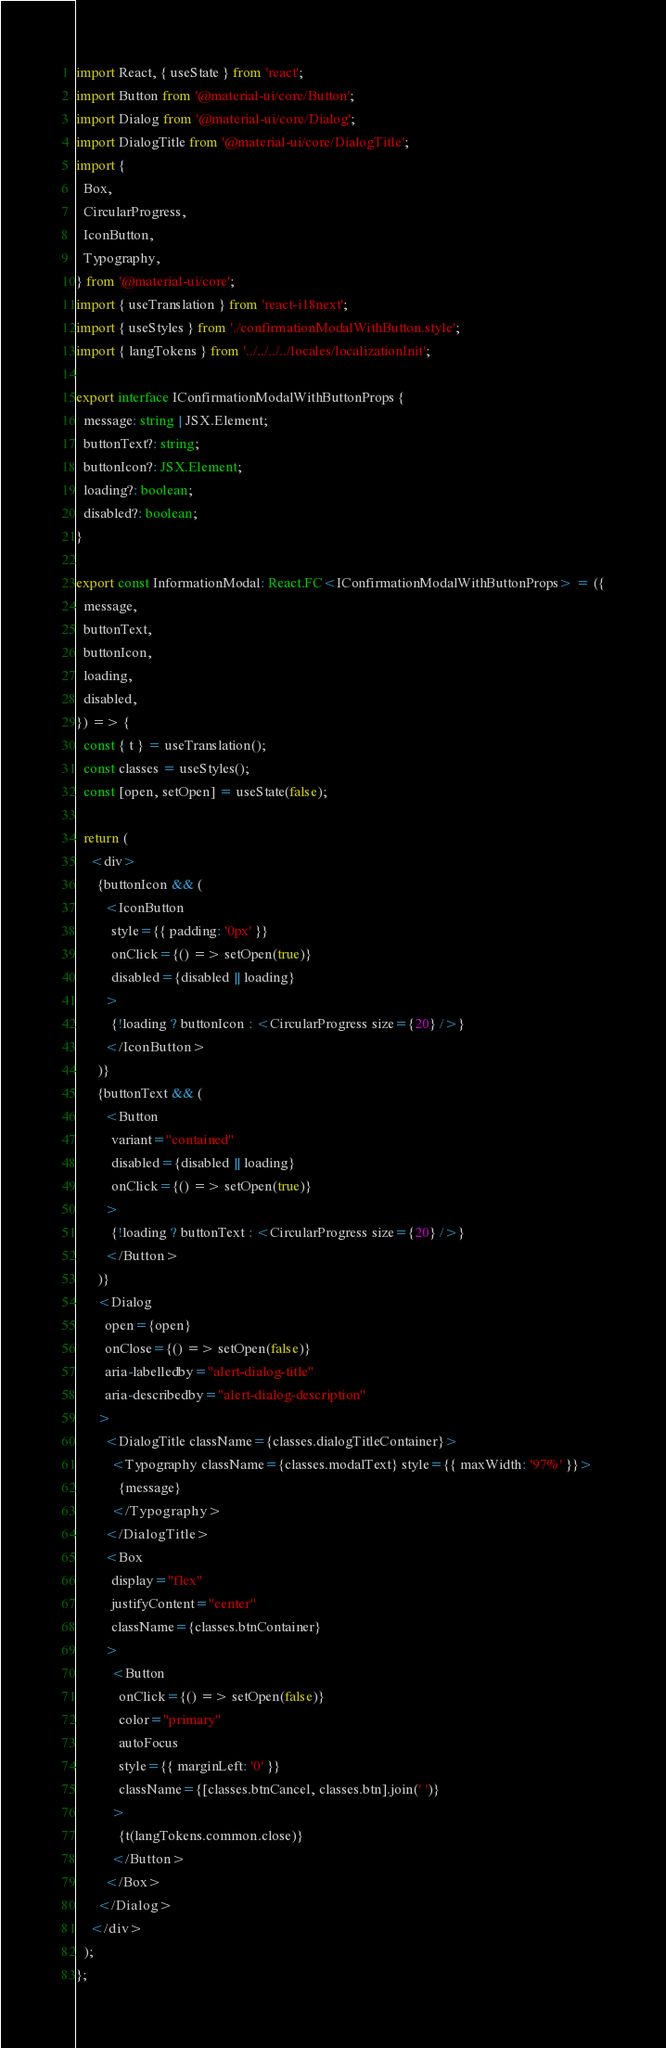<code> <loc_0><loc_0><loc_500><loc_500><_TypeScript_>import React, { useState } from 'react';
import Button from '@material-ui/core/Button';
import Dialog from '@material-ui/core/Dialog';
import DialogTitle from '@material-ui/core/DialogTitle';
import {
  Box,
  CircularProgress,
  IconButton,
  Typography,
} from '@material-ui/core';
import { useTranslation } from 'react-i18next';
import { useStyles } from './confirmationModalWithButton.style';
import { langTokens } from '../../../../locales/localizationInit';

export interface IConfirmationModalWithButtonProps {
  message: string | JSX.Element;
  buttonText?: string;
  buttonIcon?: JSX.Element;
  loading?: boolean;
  disabled?: boolean;
}

export const InformationModal: React.FC<IConfirmationModalWithButtonProps> = ({
  message,
  buttonText,
  buttonIcon,
  loading,
  disabled,
}) => {
  const { t } = useTranslation();
  const classes = useStyles();
  const [open, setOpen] = useState(false);

  return (
    <div>
      {buttonIcon && (
        <IconButton
          style={{ padding: '0px' }}
          onClick={() => setOpen(true)}
          disabled={disabled || loading}
        >
          {!loading ? buttonIcon : <CircularProgress size={20} />}
        </IconButton>
      )}
      {buttonText && (
        <Button
          variant="contained"
          disabled={disabled || loading}
          onClick={() => setOpen(true)}
        >
          {!loading ? buttonText : <CircularProgress size={20} />}
        </Button>
      )}
      <Dialog
        open={open}
        onClose={() => setOpen(false)}
        aria-labelledby="alert-dialog-title"
        aria-describedby="alert-dialog-description"
      >
        <DialogTitle className={classes.dialogTitleContainer}>
          <Typography className={classes.modalText} style={{ maxWidth: '97%' }}>
            {message}
          </Typography>
        </DialogTitle>
        <Box
          display="flex"
          justifyContent="center"
          className={classes.btnContainer}
        >
          <Button
            onClick={() => setOpen(false)}
            color="primary"
            autoFocus
            style={{ marginLeft: '0' }}
            className={[classes.btnCancel, classes.btn].join(' ')}
          >
            {t(langTokens.common.close)}
          </Button>
        </Box>
      </Dialog>
    </div>
  );
};
</code> 